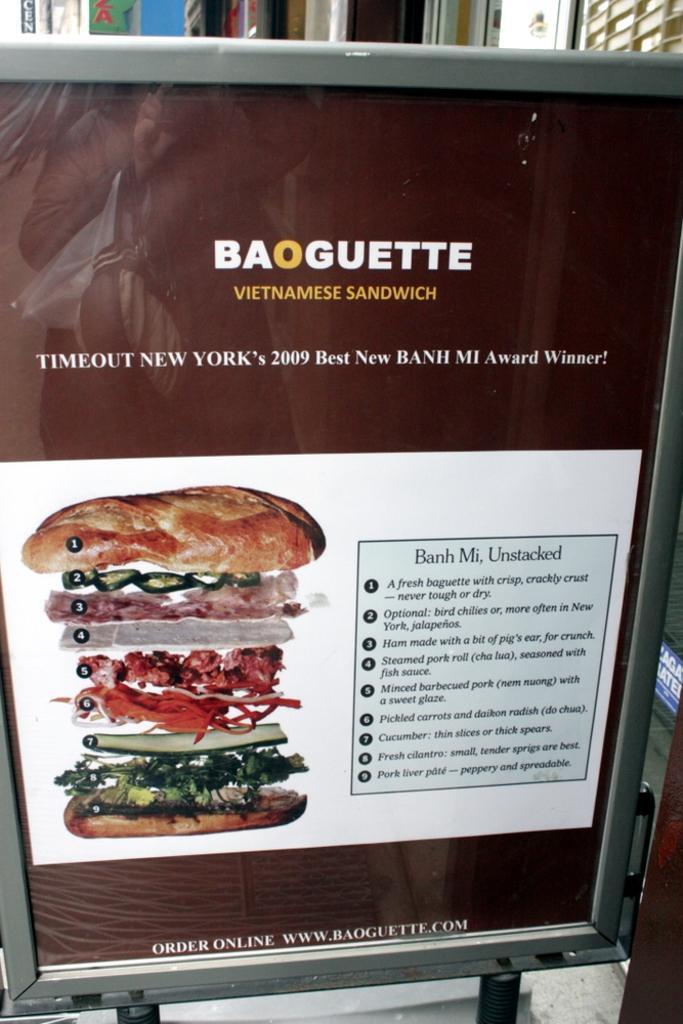Please provide a concise description of this image. There is a board with a poster. On that something is written. Also there is a food item. 